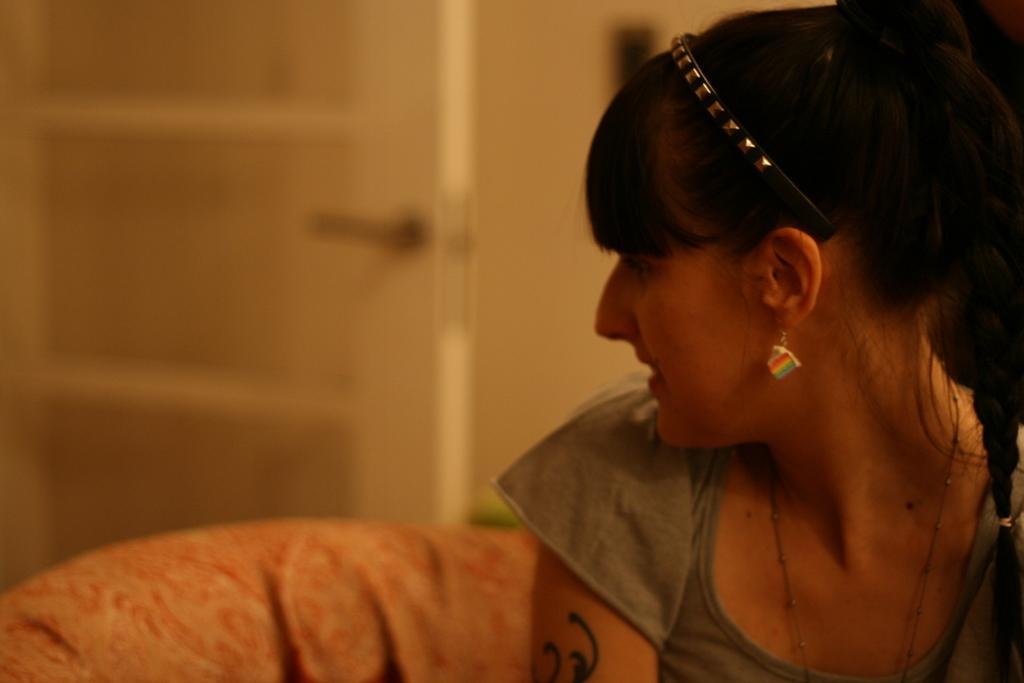Please provide a concise description of this image. This picture is taken inside the room. In this image, on the right side, we can see a woman sitting on the couch. On the left side, we can also see the red color cloth. In the background, we can see a door and wall. 